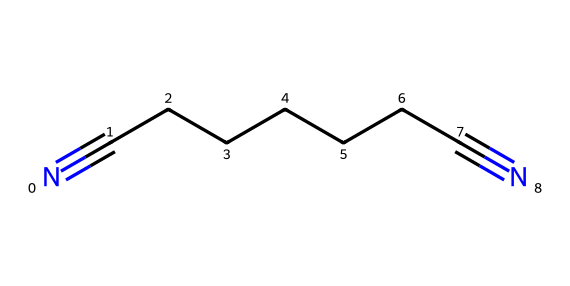What is the common name of the chemical represented by this SMILES notation? The SMILES notation provided corresponds to a linear chain of carbon atoms with two terminal nitrile groups (-C≡N). This compound is recognized as adiponitrile, commonly used in the production of nylon.
Answer: adiponitrile How many carbon atoms are present in the structure? The structure indicated by the SMILES representation shows a linear chain with seven carbon atoms (C₇) between the two nitrile groups. We count the 'C's in sequence between the nitrogen atoms.
Answer: 7 What type of functional groups are present in this chemical? The presence of the -C≡N functional groups at both ends of the carbon chain indicates that this compound contains two nitrile (-CN) groups. Each "N#" notation in the SMILES represents one nitrile functional group.
Answer: nitrile What is the total number of nitrogen atoms in this chemical? From the SMILES representation, there are two "N" atoms at either end of the carbon chain. Thus, counting the "N" symbols gives us a total of two nitrogen atoms in the molecular structure.
Answer: 2 How many double or triple bonds are illustrated in this structure? The structure features two triple bonds formed between the carbon and nitrogen atoms (the nitrile groups). Each "N#" indicates one triple bond, contributing to the total number of bonds present in the chemical.
Answer: 2 Which type of chemical is adiponitrile? Adiponitrile is classified as a nitrile because it contains the -C≡N groups, which are characteristic of nitriles. This classification is based on the presence of the nitrile functional group within the molecular structure.
Answer: nitrile 